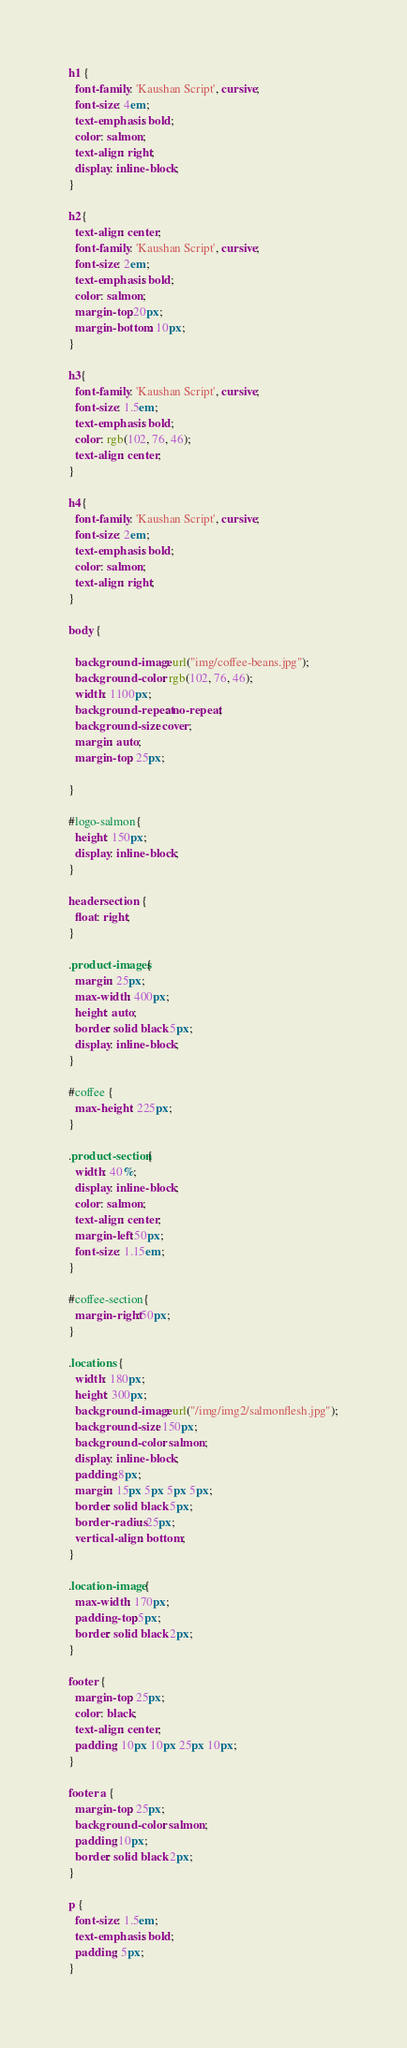<code> <loc_0><loc_0><loc_500><loc_500><_CSS_>h1 {
  font-family: 'Kaushan Script', cursive; 
  font-size: 4em;
  text-emphasis: bold;
  color: salmon;
  text-align: right;
  display: inline-block;
}

h2{
  text-align: center;
  font-family: 'Kaushan Script', cursive;
  font-size: 2em;
  text-emphasis: bold;
  color: salmon;
  margin-top:20px;
  margin-bottom: 10px;
}

h3{
  font-family: 'Kaushan Script', cursive;
  font-size: 1.5em;
  text-emphasis: bold;
  color: rgb(102, 76, 46);
  text-align: center;
}

h4{
  font-family: 'Kaushan Script', cursive;
  font-size: 2em;
  text-emphasis: bold;
  color: salmon;
  text-align: right;
}

body {
  
  background-image: url("img/coffee-beans.jpg");
  background-color: rgb(102, 76, 46);
  width: 1100px;
  background-repeat: no-repeat;
  background-size: cover;
  margin: auto;
  margin-top: 25px;

}

#logo-salmon{
  height: 150px;
  display: inline-block;
}

header section {
  float: right;
}

.product-images{
  margin: 25px;
  max-width: 400px;
  height: auto;
  border: solid black 5px;
  display: inline-block;
}

#coffee {
  max-height: 225px;
}

.product-section{
  width: 40%;
  display: inline-block;
  color: salmon;
  text-align: center;
  margin-left:50px;
  font-size: 1.15em;
}

#coffee-section{
  margin-right:50px;
}

.locations {
  width: 180px;
  height: 300px;
  background-image: url("/img/img2/salmonflesh.jpg");
  background-size: 150px;
  background-color: salmon;
  display: inline-block;
  padding:8px;
  margin: 15px 5px 5px 5px;
  border: solid black 5px;
  border-radius: 25px;
  vertical-align: bottom;
}

.location-image{
  max-width: 170px;
  padding-top:5px;
  border: solid black 2px;
}

footer {
  margin-top: 25px;
  color: black;
  text-align: center;
  padding: 10px 10px 25px 10px;
}

footer a {
  margin-top: 25px;
  background-color: salmon;
  padding:10px;
  border: solid black 2px;
}

p {
  font-size: 1.5em;
  text-emphasis: bold;
  padding: 5px;
}
</code> 